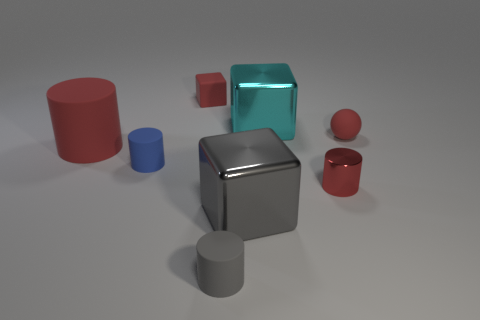Add 2 big cyan metal cubes. How many objects exist? 10 Subtract all tiny red rubber cubes. How many cubes are left? 2 Subtract all blocks. How many objects are left? 5 Add 6 gray metal objects. How many gray metal objects exist? 7 Subtract all red cylinders. How many cylinders are left? 2 Subtract 0 yellow spheres. How many objects are left? 8 Subtract 1 cylinders. How many cylinders are left? 3 Subtract all brown cylinders. Subtract all brown blocks. How many cylinders are left? 4 Subtract all red blocks. How many gray cylinders are left? 1 Subtract all large red cylinders. Subtract all large gray shiny cubes. How many objects are left? 6 